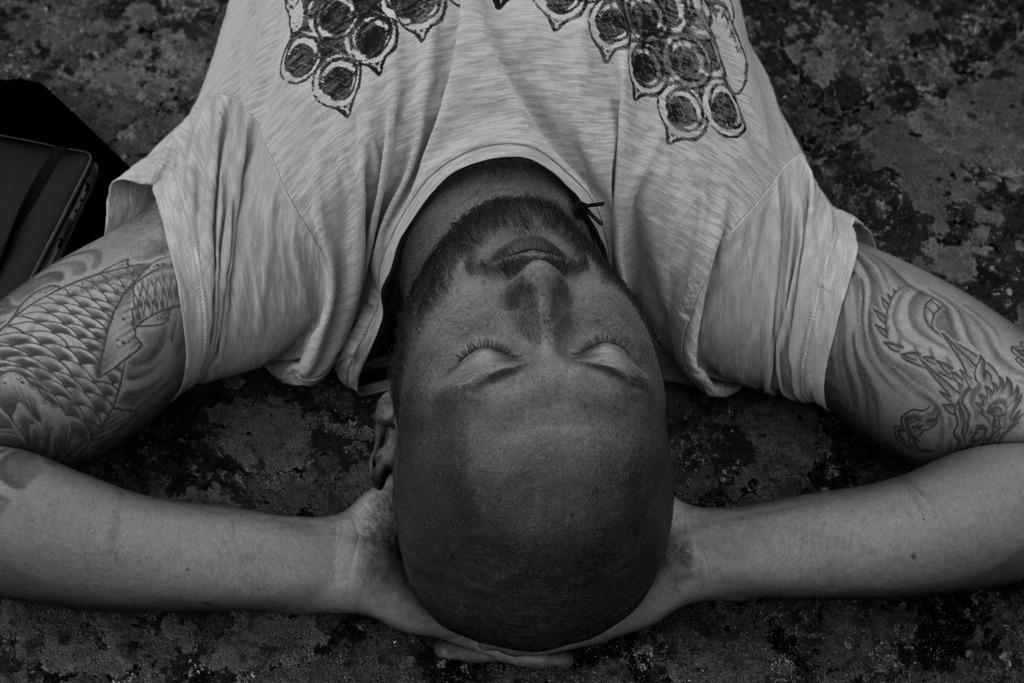Can you describe this image briefly? This image is a black and white image. At the bottom of the image there is a floor. In the middle of the image a man is lying on the floor. In the middle of the image a man is lying on the floor. On the left side of the image there is a bag on the floor. 